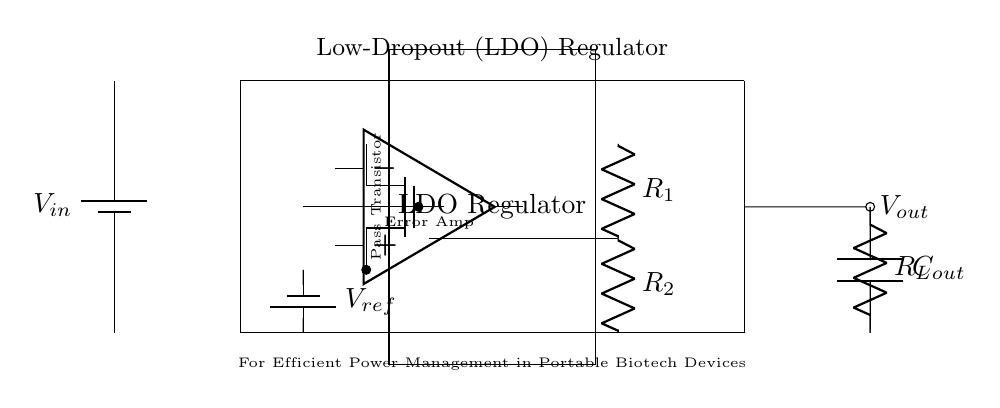What is the component that provides the output voltage? The component that provides the output voltage is the LDO regulator. It is responsible for maintaining a stable output voltage despite variations in the input voltage and load conditions.
Answer: LDO regulator What is the reference voltage component in this circuit? The reference voltage component in this circuit is represented by the battery labeled as V ref. It provides a stable voltage reference for the error amplifier to maintain the output voltage level.
Answer: V ref How many resistors are in the feedback network? There are two resistors in the feedback network, labeled as R1 and R2. They are used to set the output voltage by providing feedback to the error amplifier.
Answer: 2 What is the purpose of the error amplifier in the circuit? The purpose of the error amplifier is to compare the output voltage with the reference voltage and adjust the pass transistor accordingly to maintain a stable output voltage. It regulates the output based on feedback.
Answer: Regulation What type of transistor is used as the pass element in this LDO circuit? The type of transistor used as the pass element in this LDO circuit is a PMOS transistor. It serves to control the output current while minimizing the voltage drop across it.
Answer: PMOS What is the load connected at the output? The load connected at the output is labeled as R L. It represents the device or circuit that consumes power from the regulated output voltage.
Answer: R L What does the capacitor C out do in the output stage? The capacitor C out in the output stage serves to smooth the output voltage by filtering out high-frequency noise and providing stability during transient load conditions.
Answer: Filtering 